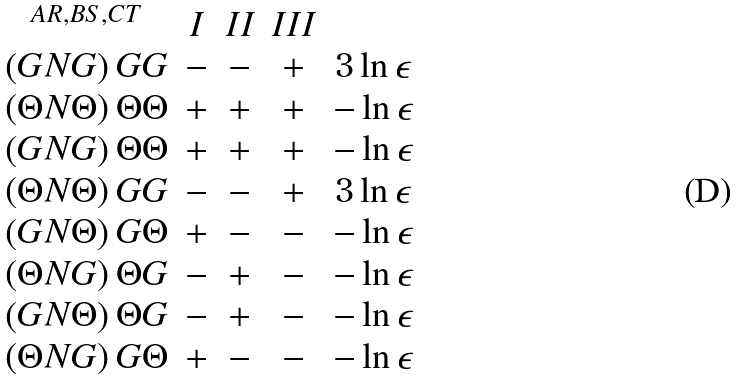<formula> <loc_0><loc_0><loc_500><loc_500>\begin{array} { c c c c c } ^ { A R , B S , C T } & I & I I & I I I & \\ \left ( G N G \right ) G G & - & - & + & 3 \ln \epsilon \\ \left ( \Theta N \Theta \right ) \Theta \Theta & + & + & + & - \ln \epsilon \\ \left ( G N G \right ) \Theta \Theta & + & + & + & - \ln \epsilon \\ \left ( \Theta N \Theta \right ) G G & - & - & + & 3 \ln \epsilon \\ \left ( G N \Theta \right ) G \Theta & + & - & - & - \ln \epsilon \\ \left ( \Theta N G \right ) \Theta G & - & + & - & - \ln \epsilon \\ \left ( G N \Theta \right ) \Theta G & - & + & - & - \ln \epsilon \\ \left ( \Theta N G \right ) G \Theta & + & - & - & - \ln \epsilon \end{array}</formula> 